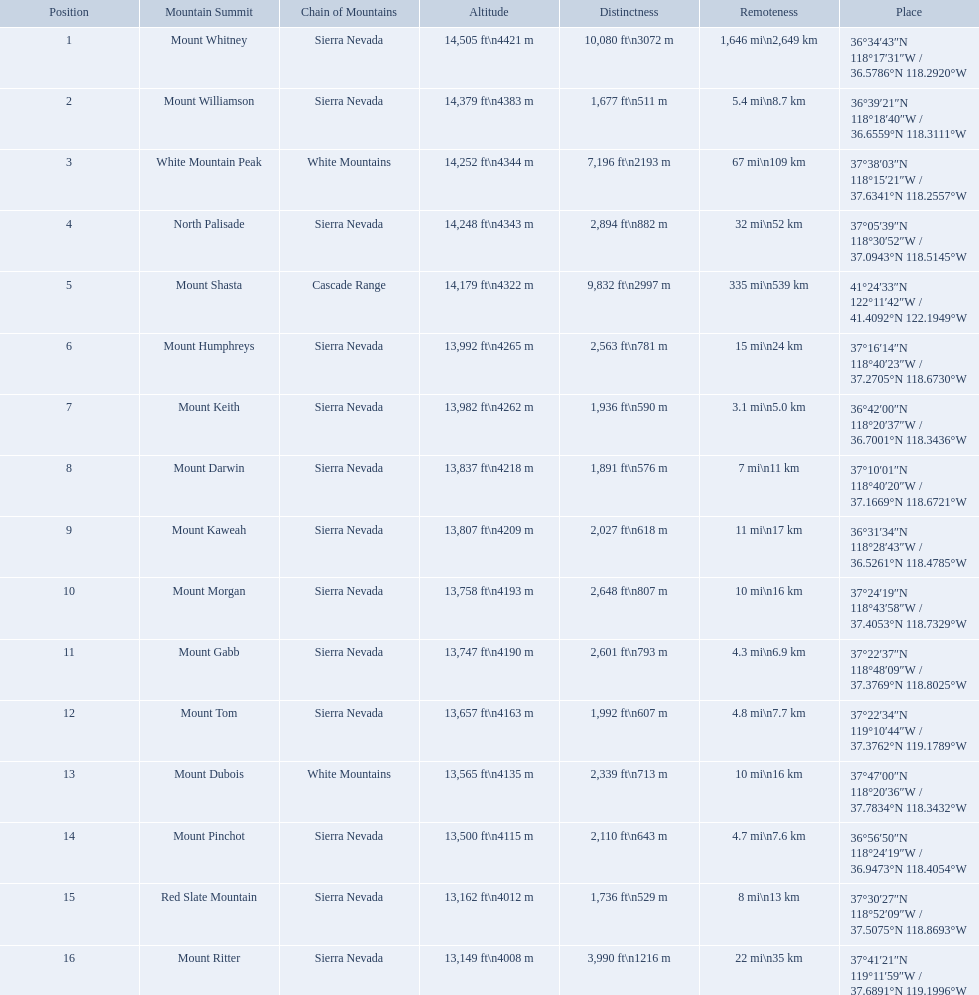What are all of the mountain peaks? Mount Whitney, Mount Williamson, White Mountain Peak, North Palisade, Mount Shasta, Mount Humphreys, Mount Keith, Mount Darwin, Mount Kaweah, Mount Morgan, Mount Gabb, Mount Tom, Mount Dubois, Mount Pinchot, Red Slate Mountain, Mount Ritter. In what ranges are they? Sierra Nevada, Sierra Nevada, White Mountains, Sierra Nevada, Cascade Range, Sierra Nevada, Sierra Nevada, Sierra Nevada, Sierra Nevada, Sierra Nevada, Sierra Nevada, Sierra Nevada, White Mountains, Sierra Nevada, Sierra Nevada, Sierra Nevada. Which peak is in the cascade range? Mount Shasta. Which mountain peaks have a prominence over 9,000 ft? Mount Whitney, Mount Shasta. Of those, which one has the the highest prominence? Mount Whitney. What are the peaks in california? Mount Whitney, Mount Williamson, White Mountain Peak, North Palisade, Mount Shasta, Mount Humphreys, Mount Keith, Mount Darwin, Mount Kaweah, Mount Morgan, Mount Gabb, Mount Tom, Mount Dubois, Mount Pinchot, Red Slate Mountain, Mount Ritter. What are the peaks in sierra nevada, california? Mount Whitney, Mount Williamson, North Palisade, Mount Humphreys, Mount Keith, Mount Darwin, Mount Kaweah, Mount Morgan, Mount Gabb, Mount Tom, Mount Pinchot, Red Slate Mountain, Mount Ritter. What are the heights of the peaks in sierra nevada? 14,505 ft\n4421 m, 14,379 ft\n4383 m, 14,248 ft\n4343 m, 13,992 ft\n4265 m, 13,982 ft\n4262 m, 13,837 ft\n4218 m, 13,807 ft\n4209 m, 13,758 ft\n4193 m, 13,747 ft\n4190 m, 13,657 ft\n4163 m, 13,500 ft\n4115 m, 13,162 ft\n4012 m, 13,149 ft\n4008 m. Which is the highest? Mount Whitney. What are all of the peaks? Mount Whitney, Mount Williamson, White Mountain Peak, North Palisade, Mount Shasta, Mount Humphreys, Mount Keith, Mount Darwin, Mount Kaweah, Mount Morgan, Mount Gabb, Mount Tom, Mount Dubois, Mount Pinchot, Red Slate Mountain, Mount Ritter. Where are they located? Sierra Nevada, Sierra Nevada, White Mountains, Sierra Nevada, Cascade Range, Sierra Nevada, Sierra Nevada, Sierra Nevada, Sierra Nevada, Sierra Nevada, Sierra Nevada, Sierra Nevada, White Mountains, Sierra Nevada, Sierra Nevada, Sierra Nevada. How tall are they? 14,505 ft\n4421 m, 14,379 ft\n4383 m, 14,252 ft\n4344 m, 14,248 ft\n4343 m, 14,179 ft\n4322 m, 13,992 ft\n4265 m, 13,982 ft\n4262 m, 13,837 ft\n4218 m, 13,807 ft\n4209 m, 13,758 ft\n4193 m, 13,747 ft\n4190 m, 13,657 ft\n4163 m, 13,565 ft\n4135 m, 13,500 ft\n4115 m, 13,162 ft\n4012 m, 13,149 ft\n4008 m. What about just the peaks in the sierra nevadas? 14,505 ft\n4421 m, 14,379 ft\n4383 m, 14,248 ft\n4343 m, 13,992 ft\n4265 m, 13,982 ft\n4262 m, 13,837 ft\n4218 m, 13,807 ft\n4209 m, 13,758 ft\n4193 m, 13,747 ft\n4190 m, 13,657 ft\n4163 m, 13,500 ft\n4115 m, 13,162 ft\n4012 m, 13,149 ft\n4008 m. And of those, which is the tallest? Mount Whitney. 